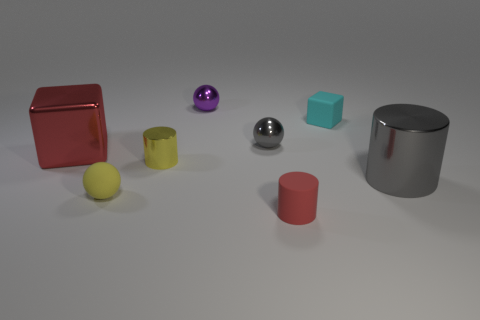Add 1 gray shiny things. How many objects exist? 9 Subtract all cylinders. How many objects are left? 5 Subtract 0 gray blocks. How many objects are left? 8 Subtract all yellow cylinders. Subtract all yellow metallic things. How many objects are left? 6 Add 2 purple metal balls. How many purple metal balls are left? 3 Add 1 large gray cylinders. How many large gray cylinders exist? 2 